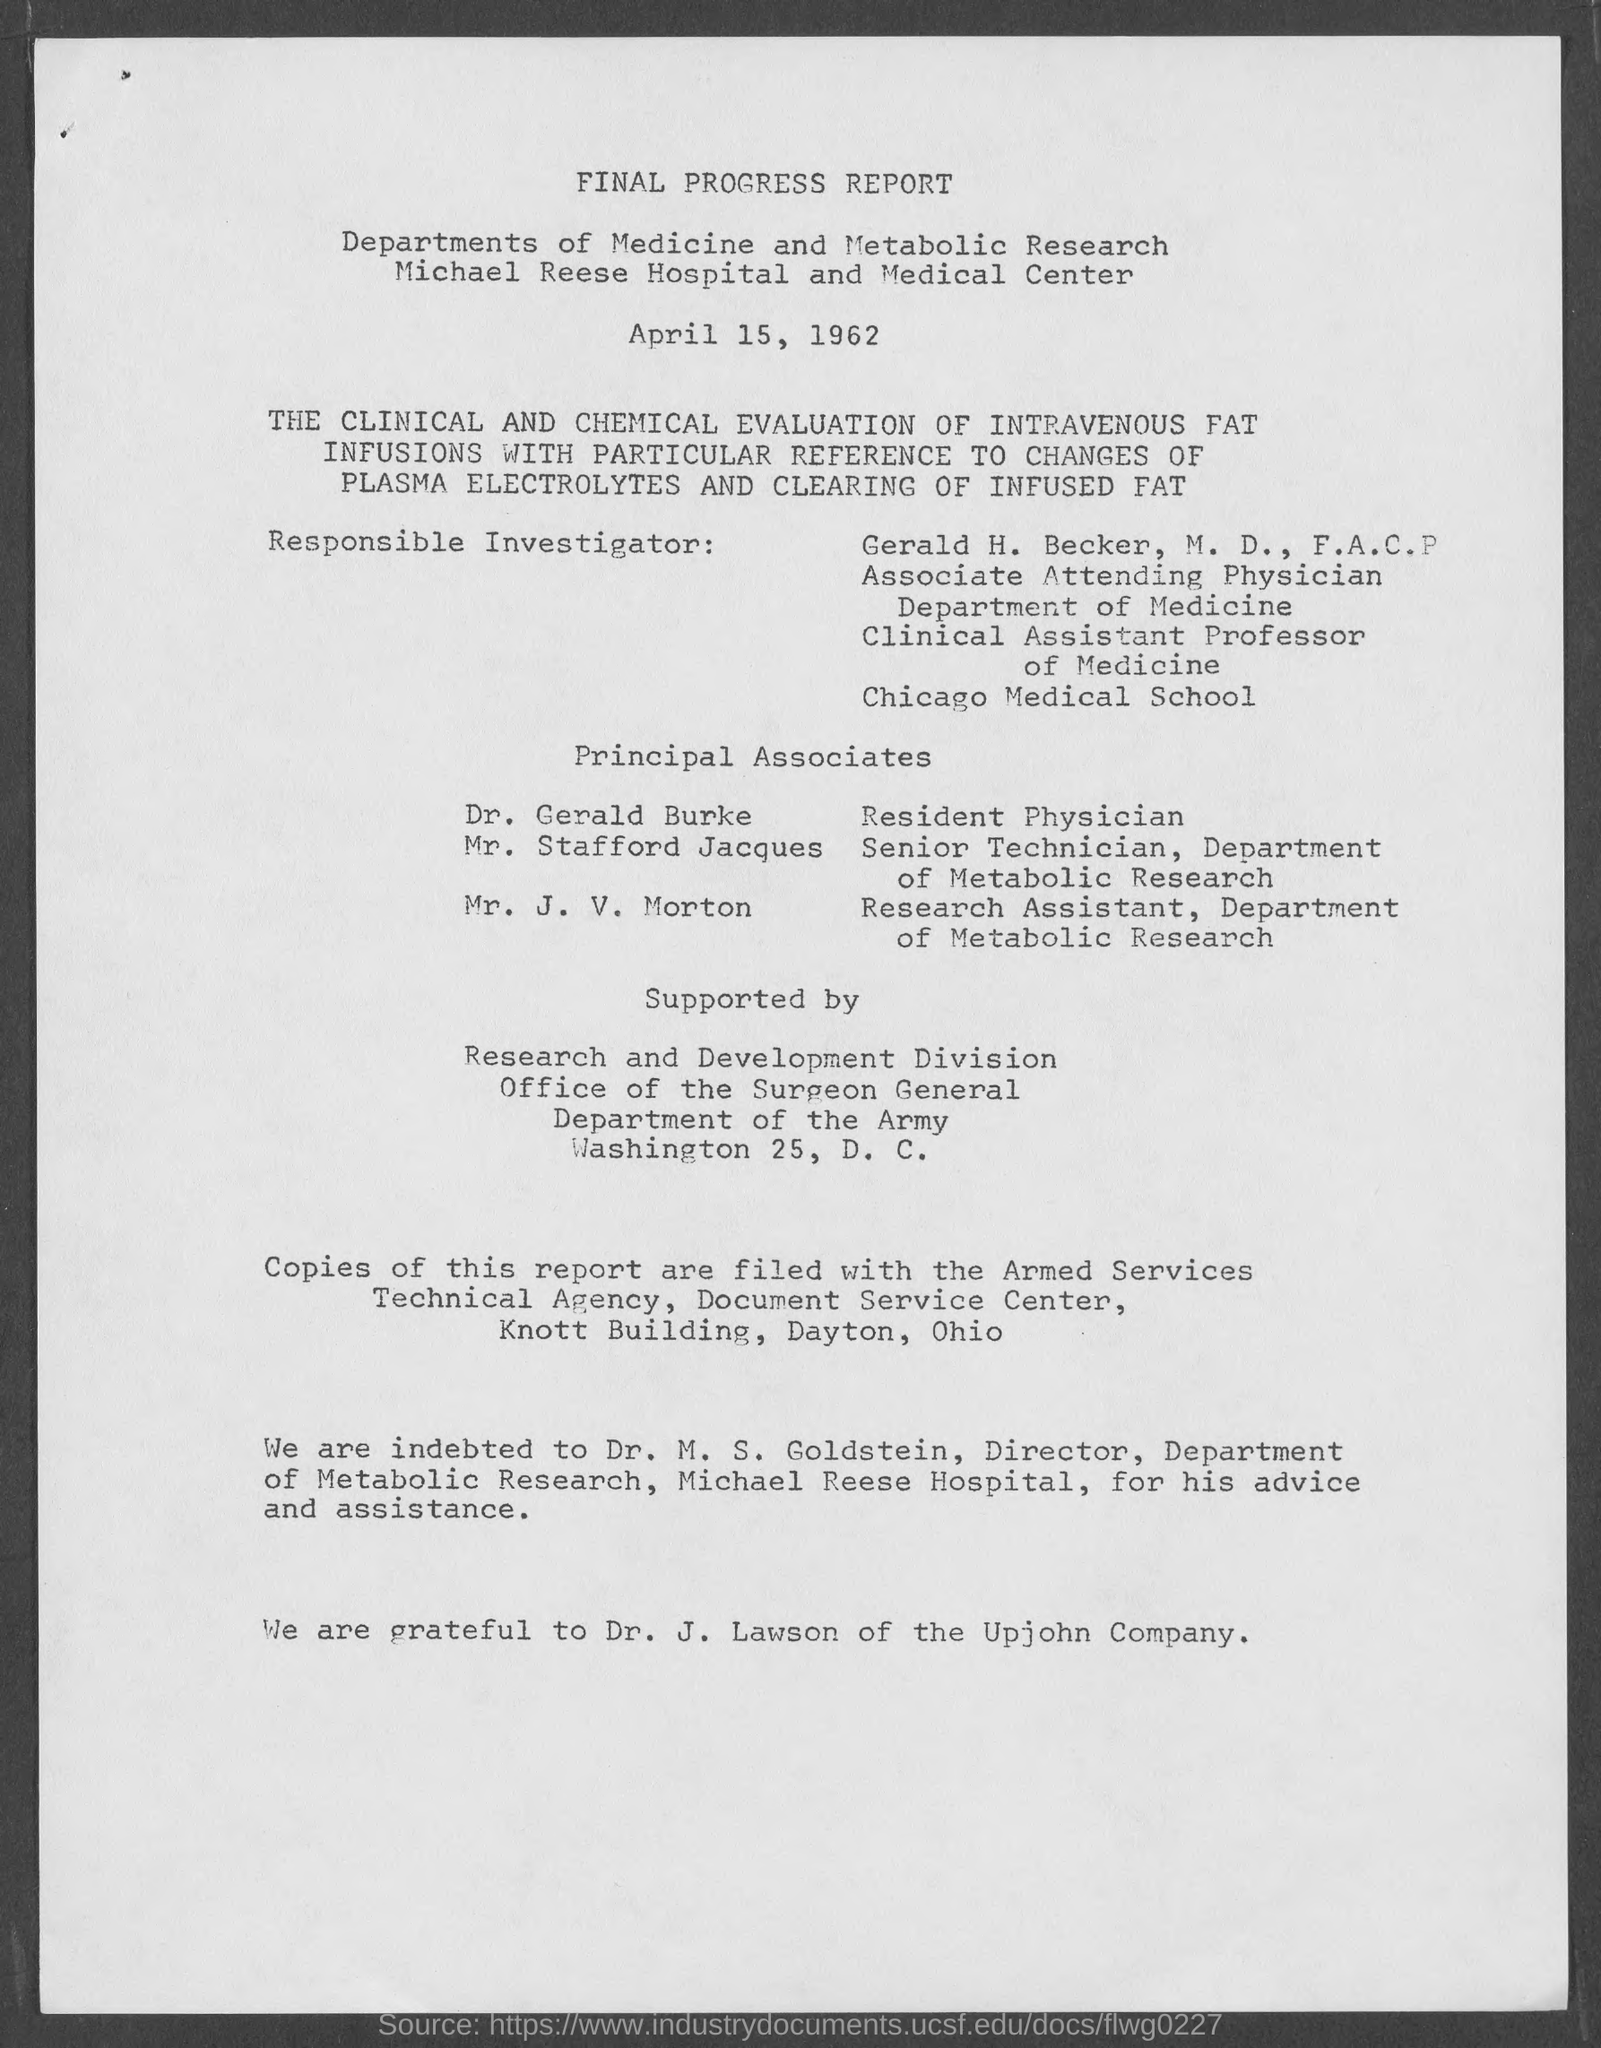What is the date of the report?
Your answer should be compact. April 15, 1962. Dr. J. Lawson belongs to which company?
Provide a succinct answer. Upjohn Company. 